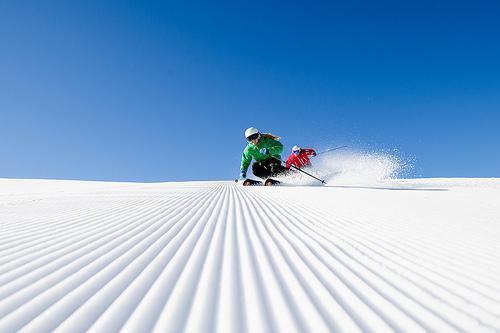How many people are in the photo?
Give a very brief answer. 2. 